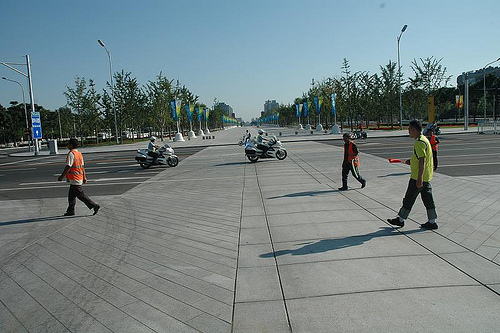<image>
Is there a middle man above the shadow? No. The middle man is not positioned above the shadow. The vertical arrangement shows a different relationship. 